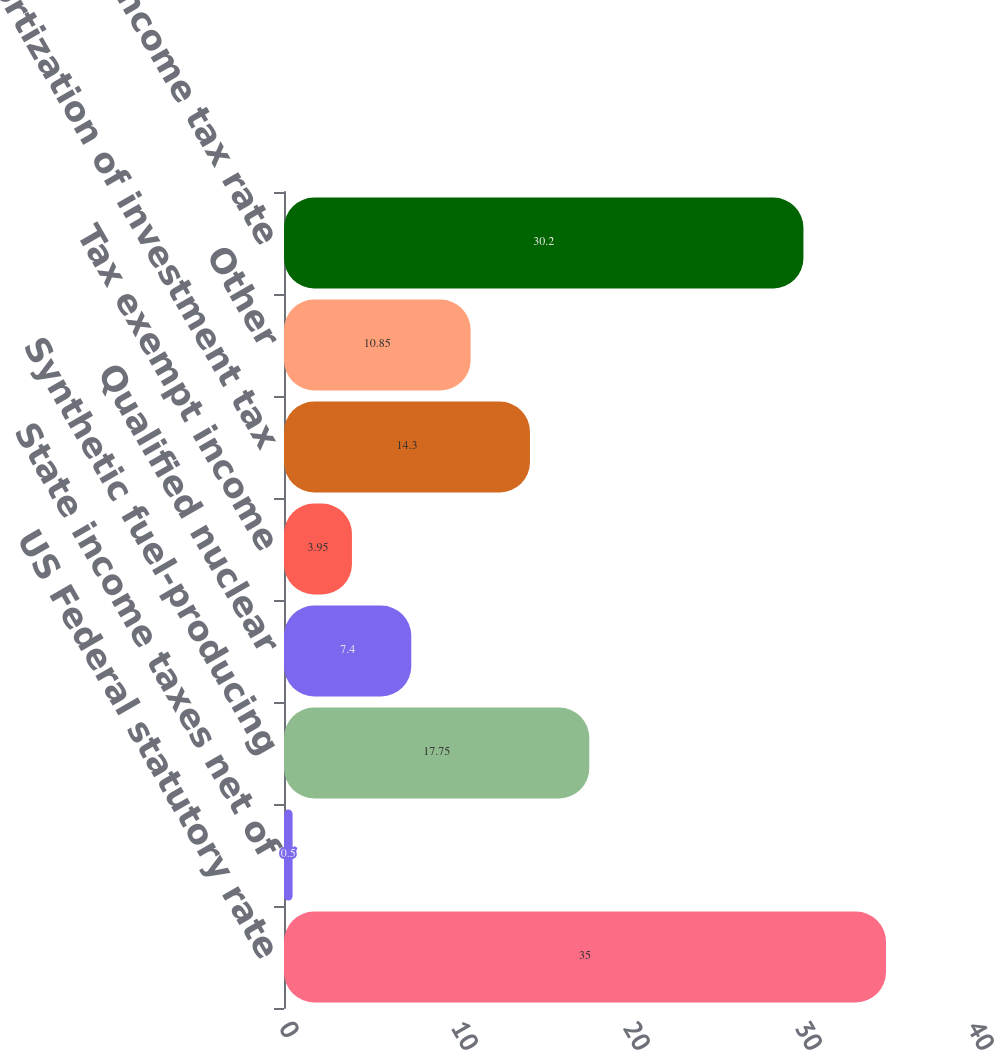<chart> <loc_0><loc_0><loc_500><loc_500><bar_chart><fcel>US Federal statutory rate<fcel>State income taxes net of<fcel>Synthetic fuel-producing<fcel>Qualified nuclear<fcel>Tax exempt income<fcel>Amortization of investment tax<fcel>Other<fcel>Effective income tax rate<nl><fcel>35<fcel>0.5<fcel>17.75<fcel>7.4<fcel>3.95<fcel>14.3<fcel>10.85<fcel>30.2<nl></chart> 